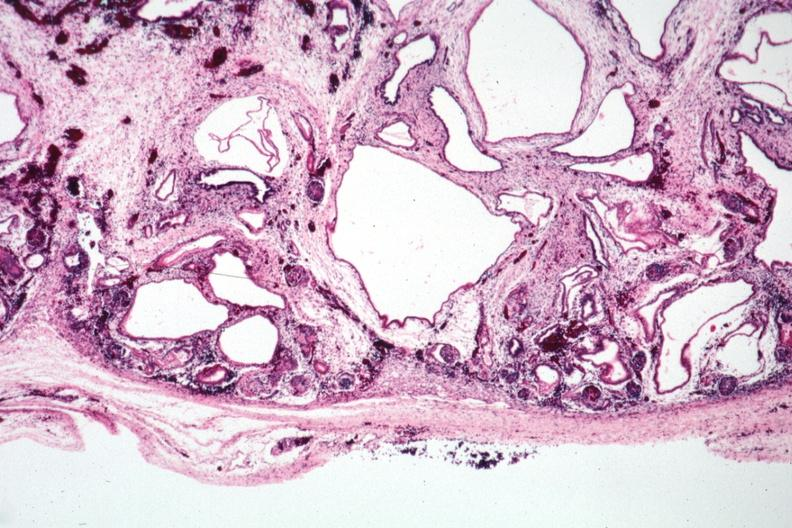s kidney present?
Answer the question using a single word or phrase. Yes 